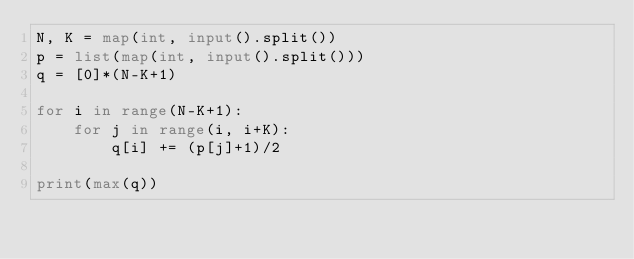<code> <loc_0><loc_0><loc_500><loc_500><_Python_>N, K = map(int, input().split())
p = list(map(int, input().split()))
q = [0]*(N-K+1)

for i in range(N-K+1):
    for j in range(i, i+K):
        q[i] += (p[j]+1)/2
        
print(max(q))</code> 